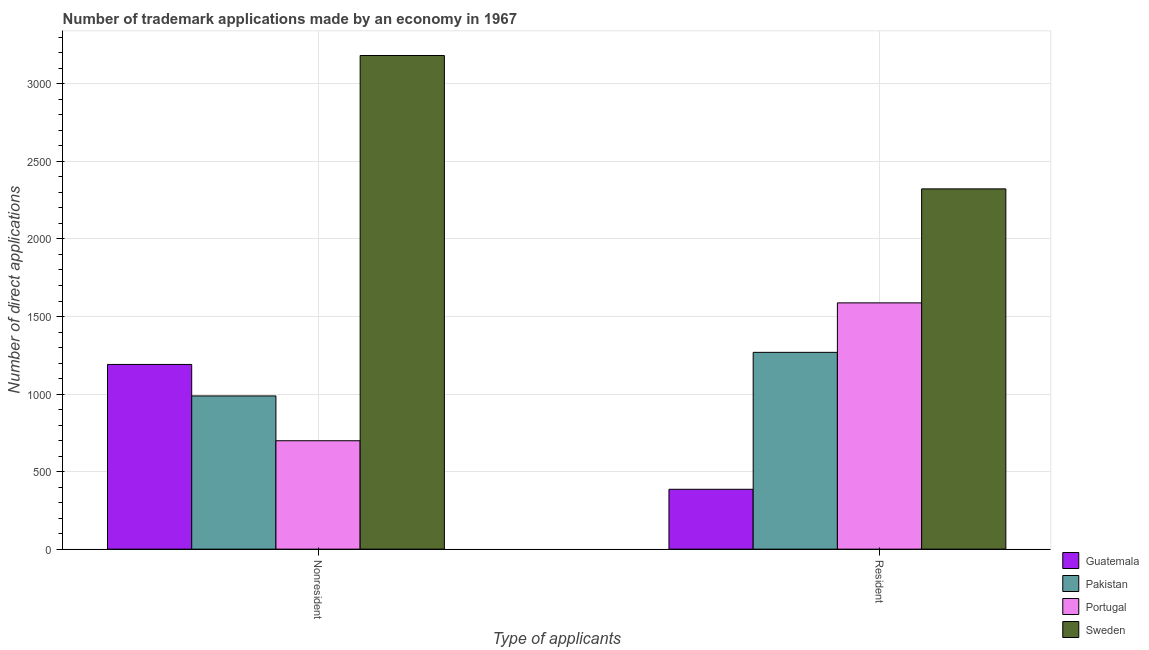How many different coloured bars are there?
Your answer should be very brief. 4. Are the number of bars per tick equal to the number of legend labels?
Provide a succinct answer. Yes. Are the number of bars on each tick of the X-axis equal?
Your answer should be very brief. Yes. How many bars are there on the 2nd tick from the right?
Provide a succinct answer. 4. What is the label of the 1st group of bars from the left?
Your answer should be compact. Nonresident. What is the number of trademark applications made by non residents in Portugal?
Provide a succinct answer. 699. Across all countries, what is the maximum number of trademark applications made by non residents?
Offer a very short reply. 3183. Across all countries, what is the minimum number of trademark applications made by non residents?
Provide a succinct answer. 699. What is the total number of trademark applications made by residents in the graph?
Provide a short and direct response. 5566. What is the difference between the number of trademark applications made by non residents in Portugal and that in Guatemala?
Keep it short and to the point. -492. What is the difference between the number of trademark applications made by residents in Guatemala and the number of trademark applications made by non residents in Sweden?
Keep it short and to the point. -2797. What is the average number of trademark applications made by non residents per country?
Your answer should be very brief. 1515.25. What is the difference between the number of trademark applications made by residents and number of trademark applications made by non residents in Sweden?
Offer a very short reply. -860. What is the ratio of the number of trademark applications made by residents in Portugal to that in Pakistan?
Your answer should be compact. 1.25. What does the 1st bar from the left in Resident represents?
Your response must be concise. Guatemala. What does the 4th bar from the right in Nonresident represents?
Provide a succinct answer. Guatemala. How many bars are there?
Offer a terse response. 8. What is the difference between two consecutive major ticks on the Y-axis?
Your answer should be compact. 500. Does the graph contain grids?
Make the answer very short. Yes. Where does the legend appear in the graph?
Give a very brief answer. Bottom right. What is the title of the graph?
Provide a succinct answer. Number of trademark applications made by an economy in 1967. Does "Poland" appear as one of the legend labels in the graph?
Keep it short and to the point. No. What is the label or title of the X-axis?
Make the answer very short. Type of applicants. What is the label or title of the Y-axis?
Offer a very short reply. Number of direct applications. What is the Number of direct applications in Guatemala in Nonresident?
Offer a terse response. 1191. What is the Number of direct applications of Pakistan in Nonresident?
Provide a short and direct response. 988. What is the Number of direct applications of Portugal in Nonresident?
Ensure brevity in your answer.  699. What is the Number of direct applications in Sweden in Nonresident?
Give a very brief answer. 3183. What is the Number of direct applications in Guatemala in Resident?
Make the answer very short. 386. What is the Number of direct applications in Pakistan in Resident?
Offer a terse response. 1269. What is the Number of direct applications in Portugal in Resident?
Offer a terse response. 1588. What is the Number of direct applications in Sweden in Resident?
Ensure brevity in your answer.  2323. Across all Type of applicants, what is the maximum Number of direct applications of Guatemala?
Keep it short and to the point. 1191. Across all Type of applicants, what is the maximum Number of direct applications in Pakistan?
Offer a terse response. 1269. Across all Type of applicants, what is the maximum Number of direct applications in Portugal?
Your answer should be very brief. 1588. Across all Type of applicants, what is the maximum Number of direct applications of Sweden?
Provide a short and direct response. 3183. Across all Type of applicants, what is the minimum Number of direct applications in Guatemala?
Provide a succinct answer. 386. Across all Type of applicants, what is the minimum Number of direct applications of Pakistan?
Offer a terse response. 988. Across all Type of applicants, what is the minimum Number of direct applications in Portugal?
Offer a very short reply. 699. Across all Type of applicants, what is the minimum Number of direct applications of Sweden?
Ensure brevity in your answer.  2323. What is the total Number of direct applications in Guatemala in the graph?
Keep it short and to the point. 1577. What is the total Number of direct applications in Pakistan in the graph?
Ensure brevity in your answer.  2257. What is the total Number of direct applications of Portugal in the graph?
Offer a terse response. 2287. What is the total Number of direct applications of Sweden in the graph?
Give a very brief answer. 5506. What is the difference between the Number of direct applications in Guatemala in Nonresident and that in Resident?
Your response must be concise. 805. What is the difference between the Number of direct applications in Pakistan in Nonresident and that in Resident?
Provide a succinct answer. -281. What is the difference between the Number of direct applications of Portugal in Nonresident and that in Resident?
Your answer should be very brief. -889. What is the difference between the Number of direct applications of Sweden in Nonresident and that in Resident?
Ensure brevity in your answer.  860. What is the difference between the Number of direct applications of Guatemala in Nonresident and the Number of direct applications of Pakistan in Resident?
Provide a short and direct response. -78. What is the difference between the Number of direct applications in Guatemala in Nonresident and the Number of direct applications in Portugal in Resident?
Offer a very short reply. -397. What is the difference between the Number of direct applications in Guatemala in Nonresident and the Number of direct applications in Sweden in Resident?
Provide a short and direct response. -1132. What is the difference between the Number of direct applications in Pakistan in Nonresident and the Number of direct applications in Portugal in Resident?
Offer a very short reply. -600. What is the difference between the Number of direct applications in Pakistan in Nonresident and the Number of direct applications in Sweden in Resident?
Your answer should be compact. -1335. What is the difference between the Number of direct applications of Portugal in Nonresident and the Number of direct applications of Sweden in Resident?
Provide a short and direct response. -1624. What is the average Number of direct applications in Guatemala per Type of applicants?
Make the answer very short. 788.5. What is the average Number of direct applications in Pakistan per Type of applicants?
Keep it short and to the point. 1128.5. What is the average Number of direct applications in Portugal per Type of applicants?
Keep it short and to the point. 1143.5. What is the average Number of direct applications in Sweden per Type of applicants?
Provide a succinct answer. 2753. What is the difference between the Number of direct applications of Guatemala and Number of direct applications of Pakistan in Nonresident?
Give a very brief answer. 203. What is the difference between the Number of direct applications in Guatemala and Number of direct applications in Portugal in Nonresident?
Your response must be concise. 492. What is the difference between the Number of direct applications in Guatemala and Number of direct applications in Sweden in Nonresident?
Offer a very short reply. -1992. What is the difference between the Number of direct applications in Pakistan and Number of direct applications in Portugal in Nonresident?
Your answer should be very brief. 289. What is the difference between the Number of direct applications of Pakistan and Number of direct applications of Sweden in Nonresident?
Give a very brief answer. -2195. What is the difference between the Number of direct applications in Portugal and Number of direct applications in Sweden in Nonresident?
Make the answer very short. -2484. What is the difference between the Number of direct applications in Guatemala and Number of direct applications in Pakistan in Resident?
Your response must be concise. -883. What is the difference between the Number of direct applications of Guatemala and Number of direct applications of Portugal in Resident?
Give a very brief answer. -1202. What is the difference between the Number of direct applications of Guatemala and Number of direct applications of Sweden in Resident?
Provide a succinct answer. -1937. What is the difference between the Number of direct applications in Pakistan and Number of direct applications in Portugal in Resident?
Your response must be concise. -319. What is the difference between the Number of direct applications of Pakistan and Number of direct applications of Sweden in Resident?
Your answer should be very brief. -1054. What is the difference between the Number of direct applications in Portugal and Number of direct applications in Sweden in Resident?
Make the answer very short. -735. What is the ratio of the Number of direct applications of Guatemala in Nonresident to that in Resident?
Your answer should be very brief. 3.09. What is the ratio of the Number of direct applications in Pakistan in Nonresident to that in Resident?
Ensure brevity in your answer.  0.78. What is the ratio of the Number of direct applications of Portugal in Nonresident to that in Resident?
Give a very brief answer. 0.44. What is the ratio of the Number of direct applications of Sweden in Nonresident to that in Resident?
Your response must be concise. 1.37. What is the difference between the highest and the second highest Number of direct applications in Guatemala?
Your response must be concise. 805. What is the difference between the highest and the second highest Number of direct applications in Pakistan?
Give a very brief answer. 281. What is the difference between the highest and the second highest Number of direct applications of Portugal?
Provide a succinct answer. 889. What is the difference between the highest and the second highest Number of direct applications of Sweden?
Offer a terse response. 860. What is the difference between the highest and the lowest Number of direct applications in Guatemala?
Make the answer very short. 805. What is the difference between the highest and the lowest Number of direct applications of Pakistan?
Offer a very short reply. 281. What is the difference between the highest and the lowest Number of direct applications of Portugal?
Make the answer very short. 889. What is the difference between the highest and the lowest Number of direct applications of Sweden?
Ensure brevity in your answer.  860. 